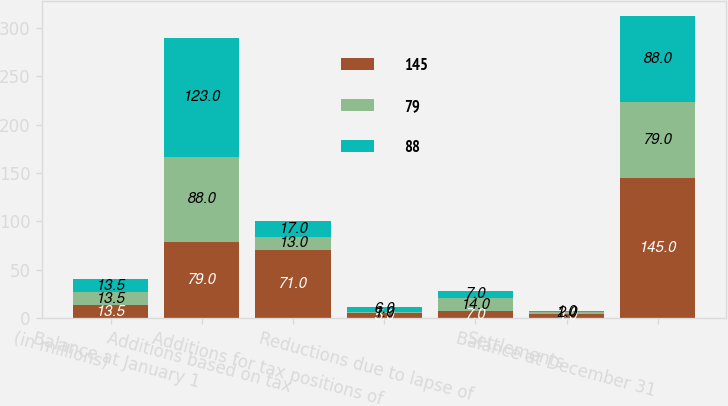<chart> <loc_0><loc_0><loc_500><loc_500><stacked_bar_chart><ecel><fcel>(in millions)<fcel>Balance at January 1<fcel>Additions based on tax<fcel>Additions for tax positions of<fcel>Reductions due to lapse of<fcel>Settlements<fcel>Balance at December 31<nl><fcel>145<fcel>13.5<fcel>79<fcel>71<fcel>5<fcel>7<fcel>4<fcel>145<nl><fcel>79<fcel>13.5<fcel>88<fcel>13<fcel>1<fcel>14<fcel>2<fcel>79<nl><fcel>88<fcel>13.5<fcel>123<fcel>17<fcel>6<fcel>7<fcel>1<fcel>88<nl></chart> 